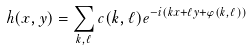Convert formula to latex. <formula><loc_0><loc_0><loc_500><loc_500>h ( x , y ) = \sum _ { k , \ell } c ( k , \ell ) e ^ { - i ( k x + \ell y + \varphi ( k , \ell ) ) }</formula> 